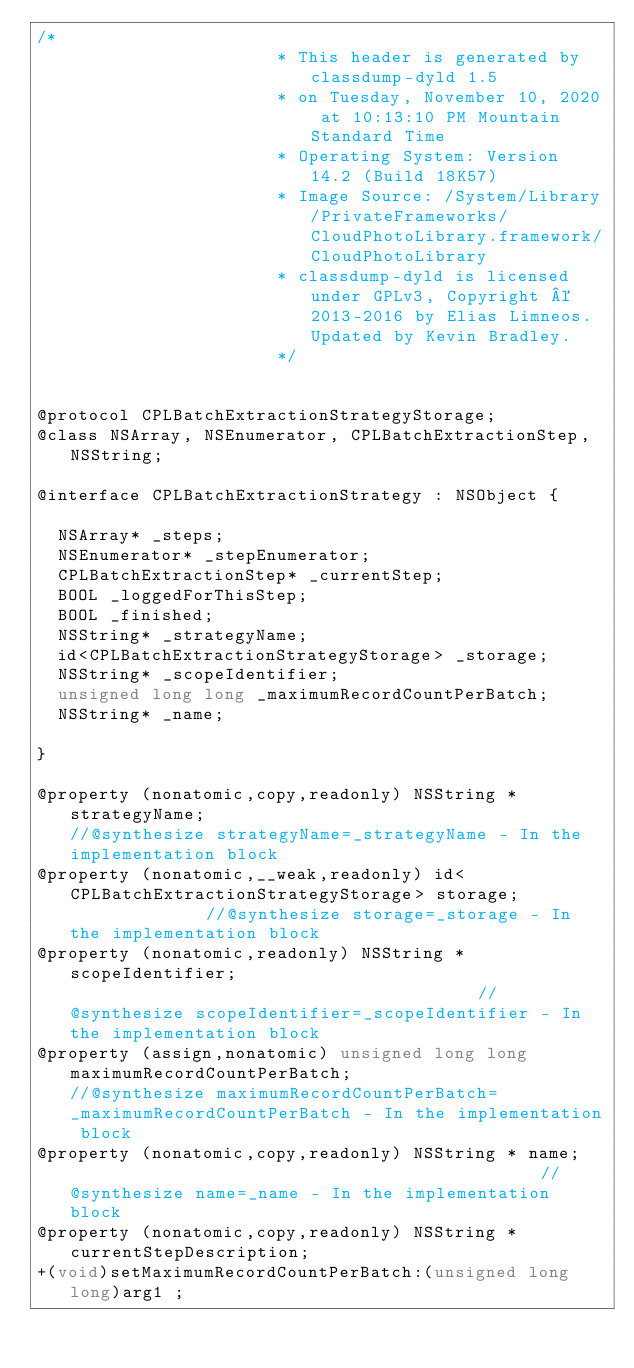Convert code to text. <code><loc_0><loc_0><loc_500><loc_500><_C_>/*
                       * This header is generated by classdump-dyld 1.5
                       * on Tuesday, November 10, 2020 at 10:13:10 PM Mountain Standard Time
                       * Operating System: Version 14.2 (Build 18K57)
                       * Image Source: /System/Library/PrivateFrameworks/CloudPhotoLibrary.framework/CloudPhotoLibrary
                       * classdump-dyld is licensed under GPLv3, Copyright © 2013-2016 by Elias Limneos. Updated by Kevin Bradley.
                       */


@protocol CPLBatchExtractionStrategyStorage;
@class NSArray, NSEnumerator, CPLBatchExtractionStep, NSString;

@interface CPLBatchExtractionStrategy : NSObject {

	NSArray* _steps;
	NSEnumerator* _stepEnumerator;
	CPLBatchExtractionStep* _currentStep;
	BOOL _loggedForThisStep;
	BOOL _finished;
	NSString* _strategyName;
	id<CPLBatchExtractionStrategyStorage> _storage;
	NSString* _scopeIdentifier;
	unsigned long long _maximumRecordCountPerBatch;
	NSString* _name;

}

@property (nonatomic,copy,readonly) NSString * strategyName;                                      //@synthesize strategyName=_strategyName - In the implementation block
@property (nonatomic,__weak,readonly) id<CPLBatchExtractionStrategyStorage> storage;              //@synthesize storage=_storage - In the implementation block
@property (nonatomic,readonly) NSString * scopeIdentifier;                                        //@synthesize scopeIdentifier=_scopeIdentifier - In the implementation block
@property (assign,nonatomic) unsigned long long maximumRecordCountPerBatch;                       //@synthesize maximumRecordCountPerBatch=_maximumRecordCountPerBatch - In the implementation block
@property (nonatomic,copy,readonly) NSString * name;                                              //@synthesize name=_name - In the implementation block
@property (nonatomic,copy,readonly) NSString * currentStepDescription; 
+(void)setMaximumRecordCountPerBatch:(unsigned long long)arg1 ;</code> 